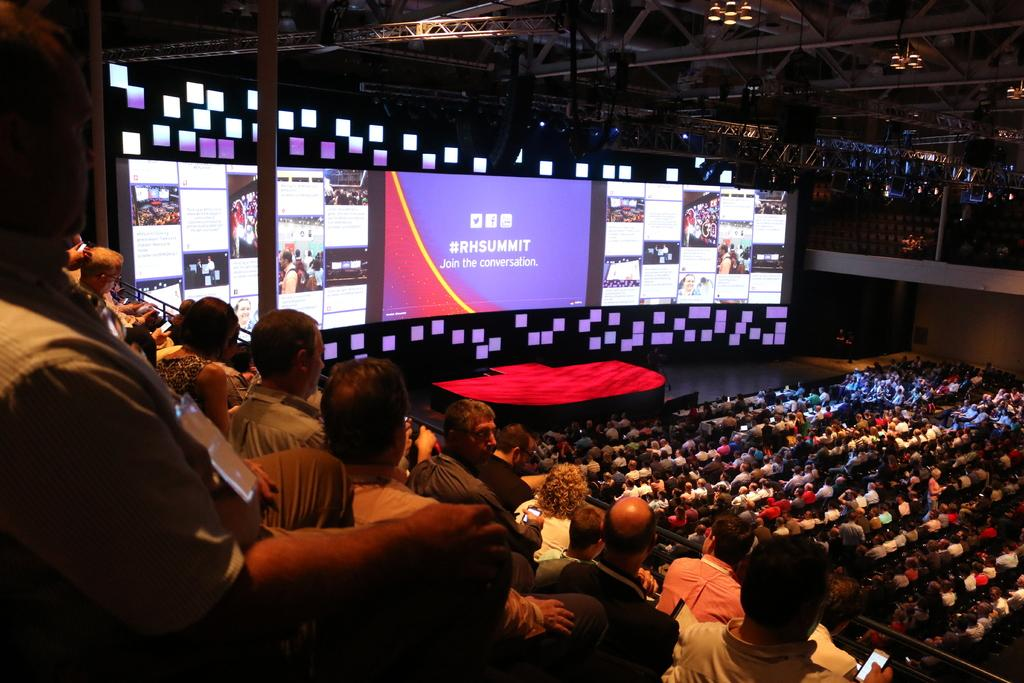What is the setting of the image? People are sitting in an auditorium. What color is the stage in the auditorium? There is a red stage in the auditorium. What additional features are present in the auditorium? There are screens present in the auditorium. Can you see a coil of rope on the stage in the image? There is no coil of rope visible on the stage in the image. Is there a tiger walking across the stage in the image? There is no tiger present in the image. 